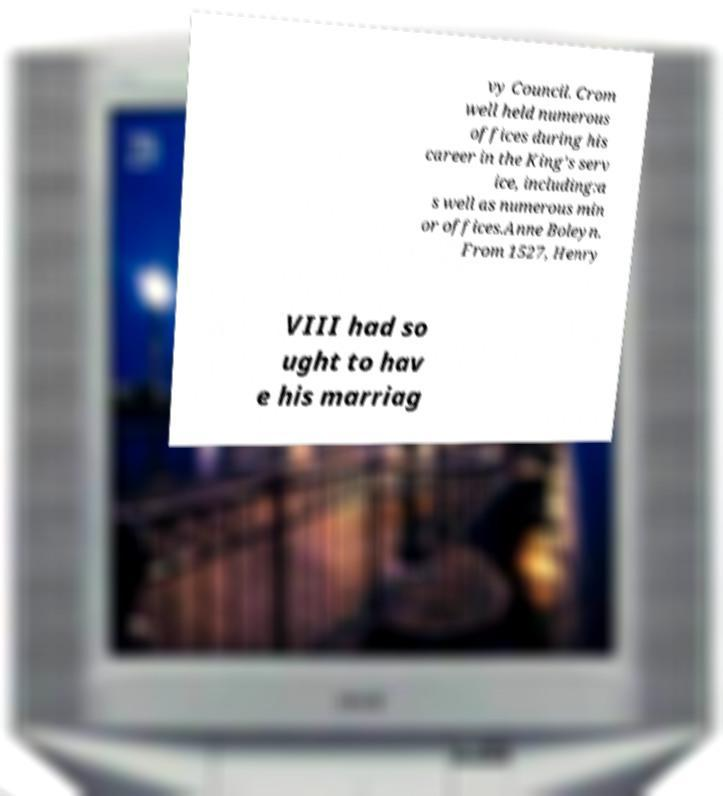Please identify and transcribe the text found in this image. vy Council. Crom well held numerous offices during his career in the King's serv ice, including:a s well as numerous min or offices.Anne Boleyn. From 1527, Henry VIII had so ught to hav e his marriag 